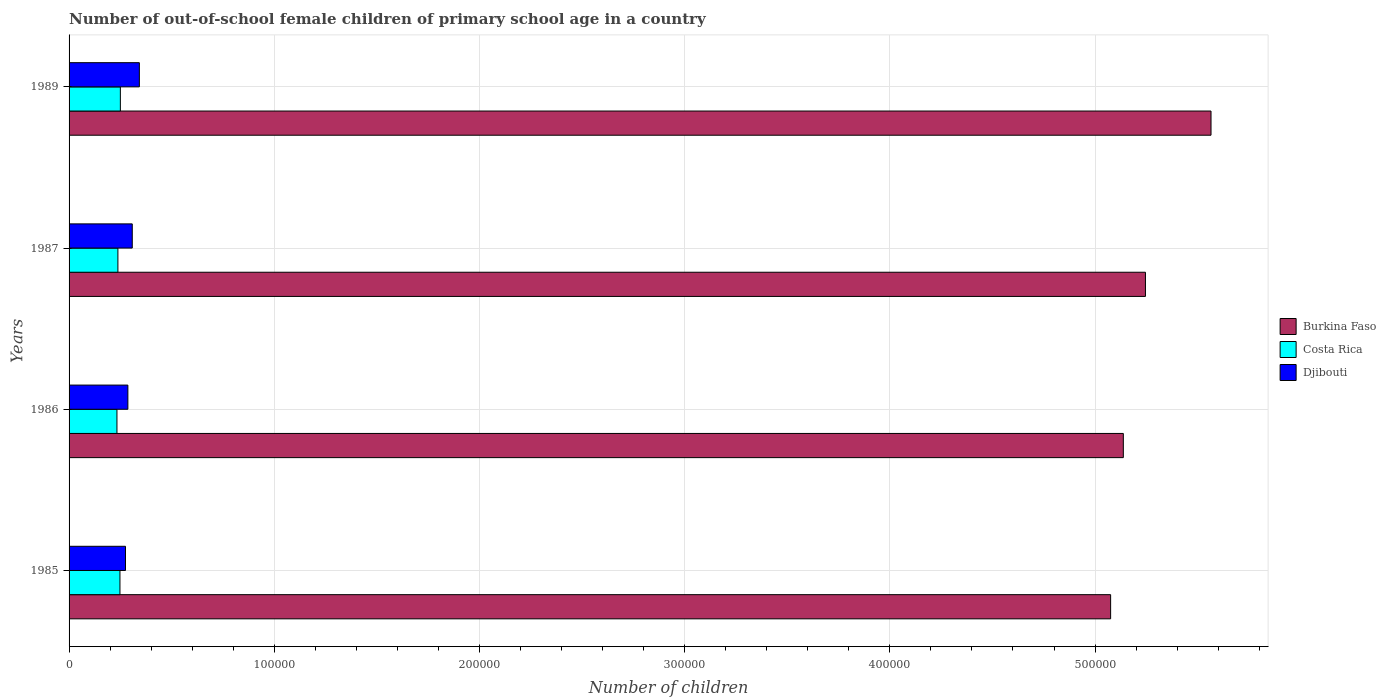Are the number of bars per tick equal to the number of legend labels?
Your answer should be compact. Yes. How many bars are there on the 3rd tick from the top?
Your answer should be very brief. 3. What is the label of the 2nd group of bars from the top?
Make the answer very short. 1987. What is the number of out-of-school female children in Burkina Faso in 1987?
Your answer should be compact. 5.25e+05. Across all years, what is the maximum number of out-of-school female children in Burkina Faso?
Your answer should be very brief. 5.57e+05. Across all years, what is the minimum number of out-of-school female children in Burkina Faso?
Give a very brief answer. 5.08e+05. What is the total number of out-of-school female children in Costa Rica in the graph?
Ensure brevity in your answer.  9.69e+04. What is the difference between the number of out-of-school female children in Djibouti in 1985 and that in 1989?
Your answer should be compact. -6760. What is the difference between the number of out-of-school female children in Costa Rica in 1985 and the number of out-of-school female children in Burkina Faso in 1986?
Provide a short and direct response. -4.89e+05. What is the average number of out-of-school female children in Djibouti per year?
Ensure brevity in your answer.  3.03e+04. In the year 1989, what is the difference between the number of out-of-school female children in Costa Rica and number of out-of-school female children in Djibouti?
Offer a terse response. -9259. What is the ratio of the number of out-of-school female children in Burkina Faso in 1985 to that in 1989?
Give a very brief answer. 0.91. Is the number of out-of-school female children in Burkina Faso in 1985 less than that in 1987?
Provide a short and direct response. Yes. Is the difference between the number of out-of-school female children in Costa Rica in 1986 and 1987 greater than the difference between the number of out-of-school female children in Djibouti in 1986 and 1987?
Your answer should be compact. Yes. What is the difference between the highest and the second highest number of out-of-school female children in Costa Rica?
Make the answer very short. 201. What is the difference between the highest and the lowest number of out-of-school female children in Burkina Faso?
Provide a succinct answer. 4.89e+04. What does the 1st bar from the bottom in 1985 represents?
Make the answer very short. Burkina Faso. How many years are there in the graph?
Offer a very short reply. 4. What is the difference between two consecutive major ticks on the X-axis?
Keep it short and to the point. 1.00e+05. Does the graph contain any zero values?
Your response must be concise. No. Does the graph contain grids?
Make the answer very short. Yes. How many legend labels are there?
Provide a short and direct response. 3. What is the title of the graph?
Provide a short and direct response. Number of out-of-school female children of primary school age in a country. What is the label or title of the X-axis?
Keep it short and to the point. Number of children. What is the Number of children of Burkina Faso in 1985?
Provide a short and direct response. 5.08e+05. What is the Number of children of Costa Rica in 1985?
Give a very brief answer. 2.48e+04. What is the Number of children of Djibouti in 1985?
Keep it short and to the point. 2.75e+04. What is the Number of children in Burkina Faso in 1986?
Make the answer very short. 5.14e+05. What is the Number of children of Costa Rica in 1986?
Ensure brevity in your answer.  2.33e+04. What is the Number of children of Djibouti in 1986?
Give a very brief answer. 2.87e+04. What is the Number of children in Burkina Faso in 1987?
Keep it short and to the point. 5.25e+05. What is the Number of children of Costa Rica in 1987?
Your response must be concise. 2.38e+04. What is the Number of children of Djibouti in 1987?
Your answer should be very brief. 3.08e+04. What is the Number of children in Burkina Faso in 1989?
Keep it short and to the point. 5.57e+05. What is the Number of children of Costa Rica in 1989?
Keep it short and to the point. 2.50e+04. What is the Number of children in Djibouti in 1989?
Your answer should be very brief. 3.43e+04. Across all years, what is the maximum Number of children of Burkina Faso?
Keep it short and to the point. 5.57e+05. Across all years, what is the maximum Number of children of Costa Rica?
Your answer should be compact. 2.50e+04. Across all years, what is the maximum Number of children of Djibouti?
Give a very brief answer. 3.43e+04. Across all years, what is the minimum Number of children in Burkina Faso?
Offer a very short reply. 5.08e+05. Across all years, what is the minimum Number of children in Costa Rica?
Your response must be concise. 2.33e+04. Across all years, what is the minimum Number of children in Djibouti?
Your answer should be very brief. 2.75e+04. What is the total Number of children of Burkina Faso in the graph?
Your answer should be compact. 2.10e+06. What is the total Number of children of Costa Rica in the graph?
Keep it short and to the point. 9.69e+04. What is the total Number of children in Djibouti in the graph?
Your answer should be very brief. 1.21e+05. What is the difference between the Number of children of Burkina Faso in 1985 and that in 1986?
Offer a very short reply. -6192. What is the difference between the Number of children in Costa Rica in 1985 and that in 1986?
Offer a very short reply. 1461. What is the difference between the Number of children of Djibouti in 1985 and that in 1986?
Your answer should be compact. -1161. What is the difference between the Number of children of Burkina Faso in 1985 and that in 1987?
Make the answer very short. -1.70e+04. What is the difference between the Number of children of Costa Rica in 1985 and that in 1987?
Make the answer very short. 995. What is the difference between the Number of children of Djibouti in 1985 and that in 1987?
Ensure brevity in your answer.  -3302. What is the difference between the Number of children in Burkina Faso in 1985 and that in 1989?
Provide a short and direct response. -4.89e+04. What is the difference between the Number of children of Costa Rica in 1985 and that in 1989?
Make the answer very short. -201. What is the difference between the Number of children in Djibouti in 1985 and that in 1989?
Offer a terse response. -6760. What is the difference between the Number of children in Burkina Faso in 1986 and that in 1987?
Keep it short and to the point. -1.08e+04. What is the difference between the Number of children of Costa Rica in 1986 and that in 1987?
Your response must be concise. -466. What is the difference between the Number of children in Djibouti in 1986 and that in 1987?
Ensure brevity in your answer.  -2141. What is the difference between the Number of children in Burkina Faso in 1986 and that in 1989?
Ensure brevity in your answer.  -4.27e+04. What is the difference between the Number of children of Costa Rica in 1986 and that in 1989?
Give a very brief answer. -1662. What is the difference between the Number of children in Djibouti in 1986 and that in 1989?
Your response must be concise. -5599. What is the difference between the Number of children in Burkina Faso in 1987 and that in 1989?
Keep it short and to the point. -3.20e+04. What is the difference between the Number of children in Costa Rica in 1987 and that in 1989?
Your answer should be very brief. -1196. What is the difference between the Number of children in Djibouti in 1987 and that in 1989?
Provide a short and direct response. -3458. What is the difference between the Number of children in Burkina Faso in 1985 and the Number of children in Costa Rica in 1986?
Your response must be concise. 4.84e+05. What is the difference between the Number of children in Burkina Faso in 1985 and the Number of children in Djibouti in 1986?
Make the answer very short. 4.79e+05. What is the difference between the Number of children in Costa Rica in 1985 and the Number of children in Djibouti in 1986?
Ensure brevity in your answer.  -3861. What is the difference between the Number of children of Burkina Faso in 1985 and the Number of children of Costa Rica in 1987?
Make the answer very short. 4.84e+05. What is the difference between the Number of children of Burkina Faso in 1985 and the Number of children of Djibouti in 1987?
Offer a terse response. 4.77e+05. What is the difference between the Number of children of Costa Rica in 1985 and the Number of children of Djibouti in 1987?
Provide a short and direct response. -6002. What is the difference between the Number of children of Burkina Faso in 1985 and the Number of children of Costa Rica in 1989?
Your response must be concise. 4.83e+05. What is the difference between the Number of children of Burkina Faso in 1985 and the Number of children of Djibouti in 1989?
Keep it short and to the point. 4.73e+05. What is the difference between the Number of children of Costa Rica in 1985 and the Number of children of Djibouti in 1989?
Offer a very short reply. -9460. What is the difference between the Number of children in Burkina Faso in 1986 and the Number of children in Costa Rica in 1987?
Offer a very short reply. 4.90e+05. What is the difference between the Number of children of Burkina Faso in 1986 and the Number of children of Djibouti in 1987?
Offer a very short reply. 4.83e+05. What is the difference between the Number of children of Costa Rica in 1986 and the Number of children of Djibouti in 1987?
Offer a terse response. -7463. What is the difference between the Number of children of Burkina Faso in 1986 and the Number of children of Costa Rica in 1989?
Offer a terse response. 4.89e+05. What is the difference between the Number of children in Burkina Faso in 1986 and the Number of children in Djibouti in 1989?
Provide a succinct answer. 4.80e+05. What is the difference between the Number of children of Costa Rica in 1986 and the Number of children of Djibouti in 1989?
Provide a short and direct response. -1.09e+04. What is the difference between the Number of children of Burkina Faso in 1987 and the Number of children of Costa Rica in 1989?
Provide a succinct answer. 5.00e+05. What is the difference between the Number of children of Burkina Faso in 1987 and the Number of children of Djibouti in 1989?
Your response must be concise. 4.90e+05. What is the difference between the Number of children of Costa Rica in 1987 and the Number of children of Djibouti in 1989?
Your answer should be very brief. -1.05e+04. What is the average Number of children in Burkina Faso per year?
Keep it short and to the point. 5.26e+05. What is the average Number of children in Costa Rica per year?
Your answer should be compact. 2.42e+04. What is the average Number of children in Djibouti per year?
Provide a succinct answer. 3.03e+04. In the year 1985, what is the difference between the Number of children in Burkina Faso and Number of children in Costa Rica?
Offer a terse response. 4.83e+05. In the year 1985, what is the difference between the Number of children in Burkina Faso and Number of children in Djibouti?
Offer a very short reply. 4.80e+05. In the year 1985, what is the difference between the Number of children of Costa Rica and Number of children of Djibouti?
Provide a succinct answer. -2700. In the year 1986, what is the difference between the Number of children in Burkina Faso and Number of children in Costa Rica?
Give a very brief answer. 4.90e+05. In the year 1986, what is the difference between the Number of children in Burkina Faso and Number of children in Djibouti?
Offer a terse response. 4.85e+05. In the year 1986, what is the difference between the Number of children of Costa Rica and Number of children of Djibouti?
Keep it short and to the point. -5322. In the year 1987, what is the difference between the Number of children of Burkina Faso and Number of children of Costa Rica?
Your response must be concise. 5.01e+05. In the year 1987, what is the difference between the Number of children in Burkina Faso and Number of children in Djibouti?
Give a very brief answer. 4.94e+05. In the year 1987, what is the difference between the Number of children of Costa Rica and Number of children of Djibouti?
Provide a succinct answer. -6997. In the year 1989, what is the difference between the Number of children of Burkina Faso and Number of children of Costa Rica?
Offer a terse response. 5.32e+05. In the year 1989, what is the difference between the Number of children in Burkina Faso and Number of children in Djibouti?
Keep it short and to the point. 5.22e+05. In the year 1989, what is the difference between the Number of children of Costa Rica and Number of children of Djibouti?
Offer a terse response. -9259. What is the ratio of the Number of children in Burkina Faso in 1985 to that in 1986?
Give a very brief answer. 0.99. What is the ratio of the Number of children of Costa Rica in 1985 to that in 1986?
Provide a short and direct response. 1.06. What is the ratio of the Number of children in Djibouti in 1985 to that in 1986?
Offer a very short reply. 0.96. What is the ratio of the Number of children in Burkina Faso in 1985 to that in 1987?
Keep it short and to the point. 0.97. What is the ratio of the Number of children of Costa Rica in 1985 to that in 1987?
Provide a short and direct response. 1.04. What is the ratio of the Number of children of Djibouti in 1985 to that in 1987?
Keep it short and to the point. 0.89. What is the ratio of the Number of children in Burkina Faso in 1985 to that in 1989?
Ensure brevity in your answer.  0.91. What is the ratio of the Number of children of Djibouti in 1985 to that in 1989?
Provide a succinct answer. 0.8. What is the ratio of the Number of children of Burkina Faso in 1986 to that in 1987?
Keep it short and to the point. 0.98. What is the ratio of the Number of children of Costa Rica in 1986 to that in 1987?
Your response must be concise. 0.98. What is the ratio of the Number of children of Djibouti in 1986 to that in 1987?
Provide a short and direct response. 0.93. What is the ratio of the Number of children of Burkina Faso in 1986 to that in 1989?
Make the answer very short. 0.92. What is the ratio of the Number of children in Costa Rica in 1986 to that in 1989?
Provide a succinct answer. 0.93. What is the ratio of the Number of children of Djibouti in 1986 to that in 1989?
Ensure brevity in your answer.  0.84. What is the ratio of the Number of children of Burkina Faso in 1987 to that in 1989?
Provide a succinct answer. 0.94. What is the ratio of the Number of children in Costa Rica in 1987 to that in 1989?
Your answer should be very brief. 0.95. What is the ratio of the Number of children in Djibouti in 1987 to that in 1989?
Your answer should be very brief. 0.9. What is the difference between the highest and the second highest Number of children in Burkina Faso?
Your answer should be very brief. 3.20e+04. What is the difference between the highest and the second highest Number of children in Costa Rica?
Ensure brevity in your answer.  201. What is the difference between the highest and the second highest Number of children of Djibouti?
Offer a terse response. 3458. What is the difference between the highest and the lowest Number of children in Burkina Faso?
Offer a terse response. 4.89e+04. What is the difference between the highest and the lowest Number of children of Costa Rica?
Keep it short and to the point. 1662. What is the difference between the highest and the lowest Number of children of Djibouti?
Your answer should be compact. 6760. 